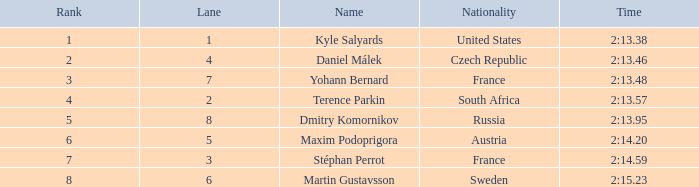What was Maxim Podoprigora's lowest rank? 6.0. 